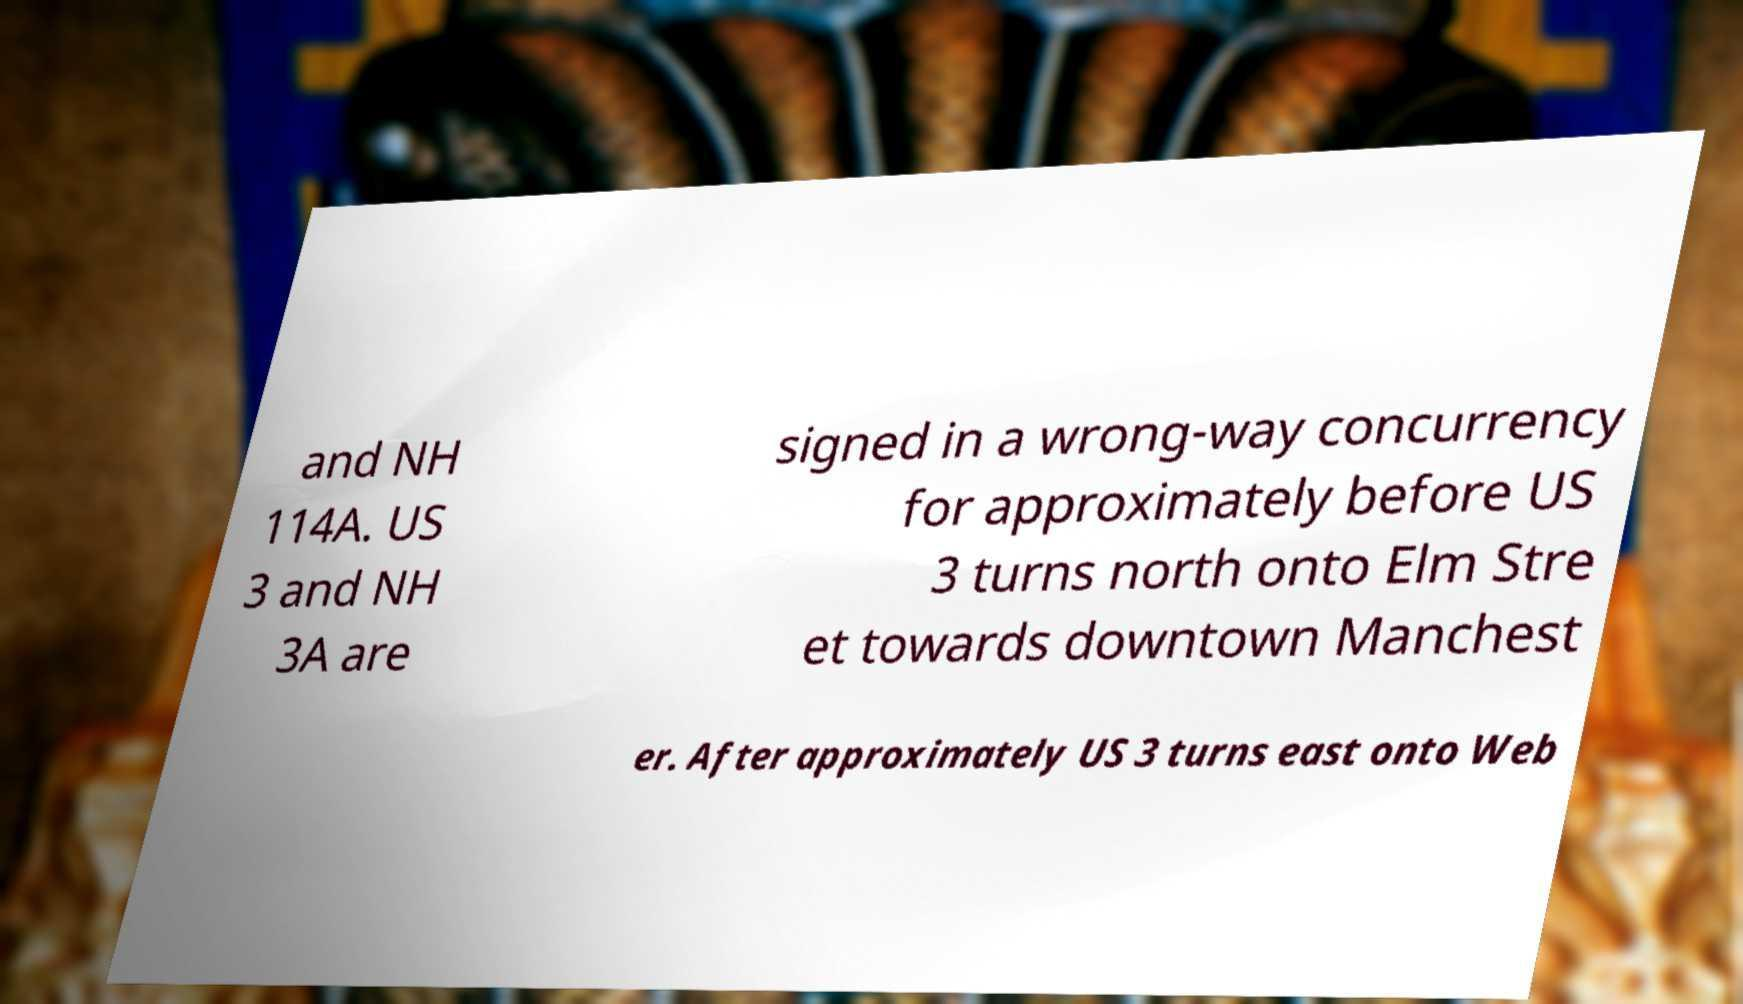Could you assist in decoding the text presented in this image and type it out clearly? and NH 114A. US 3 and NH 3A are signed in a wrong-way concurrency for approximately before US 3 turns north onto Elm Stre et towards downtown Manchest er. After approximately US 3 turns east onto Web 